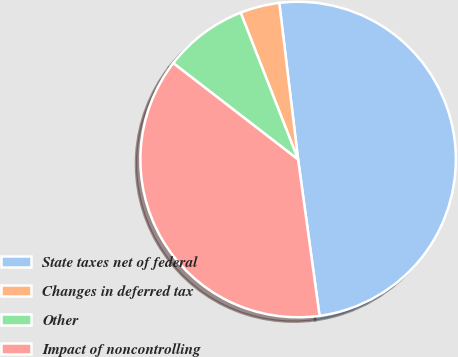Convert chart. <chart><loc_0><loc_0><loc_500><loc_500><pie_chart><fcel>State taxes net of federal<fcel>Changes in deferred tax<fcel>Other<fcel>Impact of noncontrolling<nl><fcel>49.73%<fcel>4.03%<fcel>8.6%<fcel>37.63%<nl></chart> 